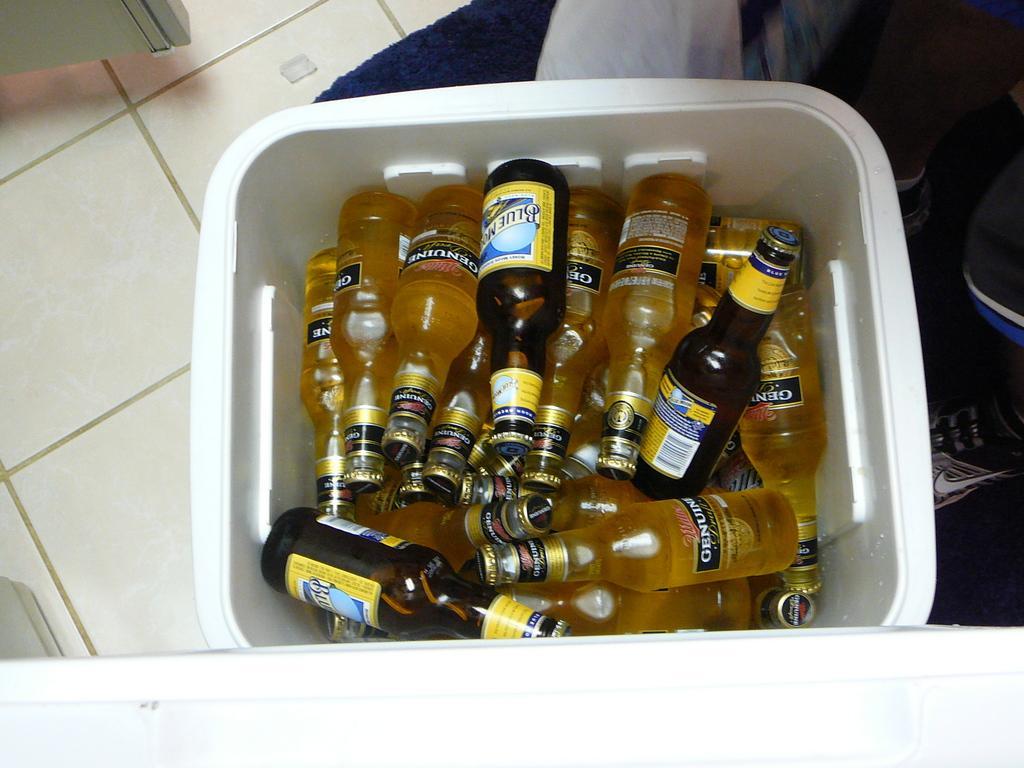How would you summarize this image in a sentence or two? As we can see in the image there is a white color tiles and bottles. 